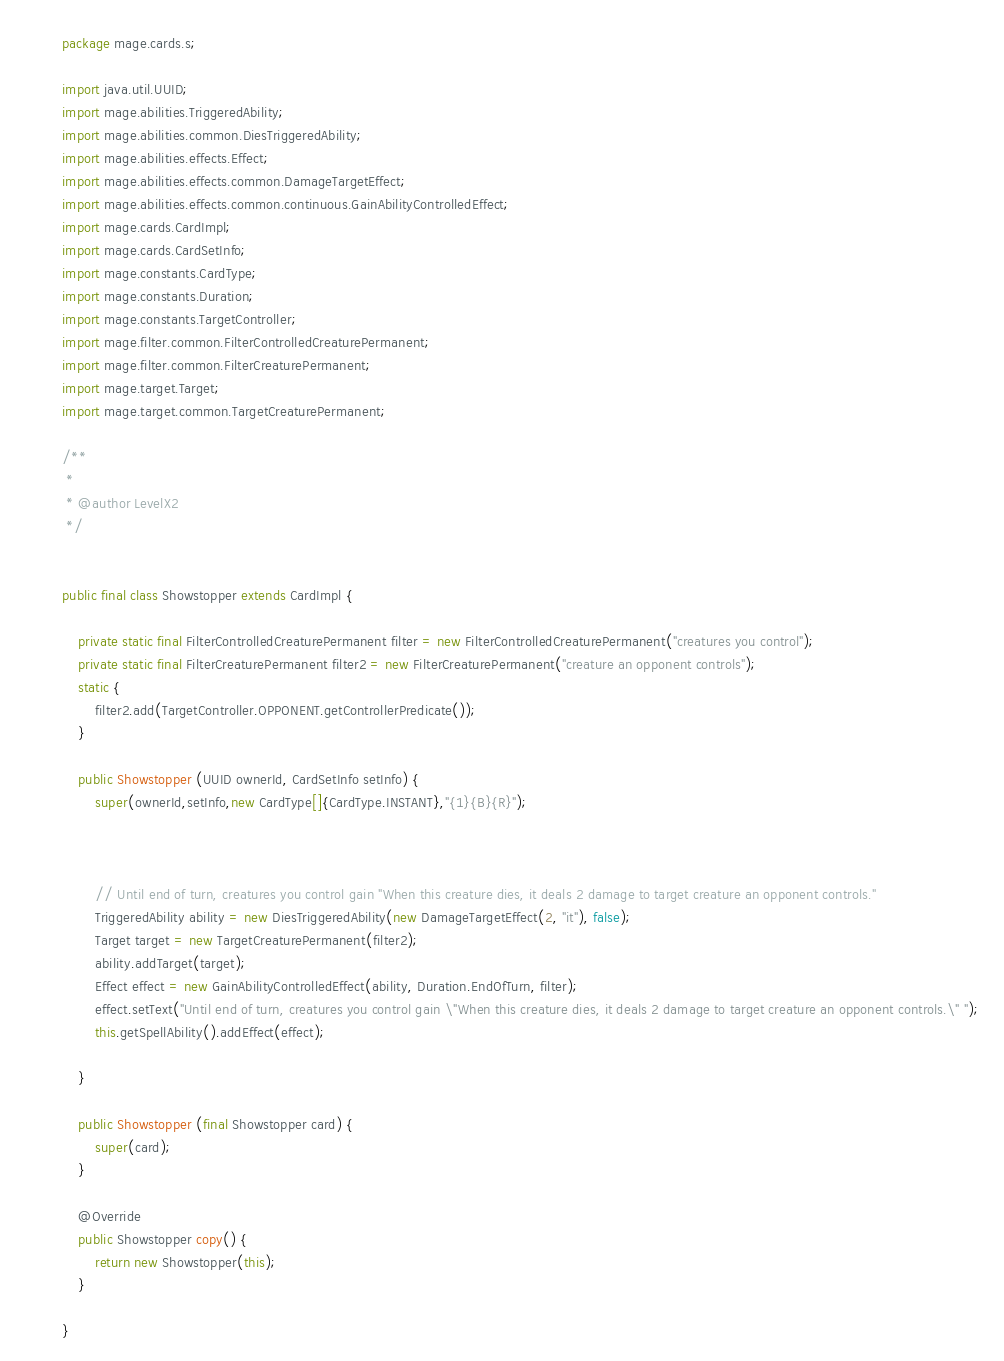Convert code to text. <code><loc_0><loc_0><loc_500><loc_500><_Java_>
package mage.cards.s;

import java.util.UUID;
import mage.abilities.TriggeredAbility;
import mage.abilities.common.DiesTriggeredAbility;
import mage.abilities.effects.Effect;
import mage.abilities.effects.common.DamageTargetEffect;
import mage.abilities.effects.common.continuous.GainAbilityControlledEffect;
import mage.cards.CardImpl;
import mage.cards.CardSetInfo;
import mage.constants.CardType;
import mage.constants.Duration;
import mage.constants.TargetController;
import mage.filter.common.FilterControlledCreaturePermanent;
import mage.filter.common.FilterCreaturePermanent;
import mage.target.Target;
import mage.target.common.TargetCreaturePermanent;

/**
 *
 * @author LevelX2
 */


public final class Showstopper extends CardImpl {

    private static final FilterControlledCreaturePermanent filter = new FilterControlledCreaturePermanent("creatures you control");
    private static final FilterCreaturePermanent filter2 = new FilterCreaturePermanent("creature an opponent controls");
    static {
        filter2.add(TargetController.OPPONENT.getControllerPredicate());
    }

    public Showstopper (UUID ownerId, CardSetInfo setInfo) {
        super(ownerId,setInfo,new CardType[]{CardType.INSTANT},"{1}{B}{R}");



        // Until end of turn, creatures you control gain "When this creature dies, it deals 2 damage to target creature an opponent controls."
        TriggeredAbility ability = new DiesTriggeredAbility(new DamageTargetEffect(2, "it"), false);
        Target target = new TargetCreaturePermanent(filter2);
        ability.addTarget(target);
        Effect effect = new GainAbilityControlledEffect(ability, Duration.EndOfTurn, filter);
        effect.setText("Until end of turn, creatures you control gain \"When this creature dies, it deals 2 damage to target creature an opponent controls.\" ");
        this.getSpellAbility().addEffect(effect);

    }

    public Showstopper (final Showstopper card) {
        super(card);
    }

    @Override
    public Showstopper copy() {
        return new Showstopper(this);
    }

}
</code> 